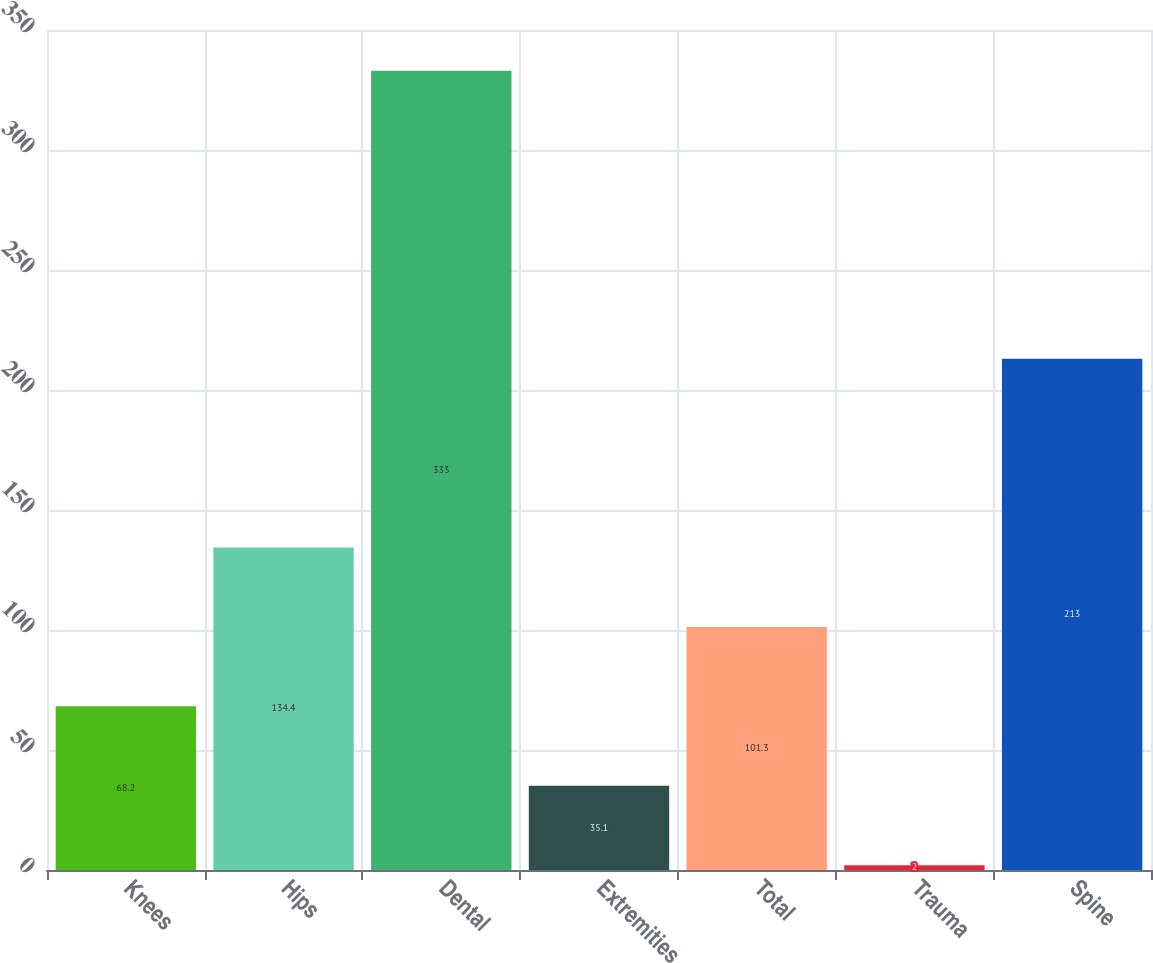Convert chart. <chart><loc_0><loc_0><loc_500><loc_500><bar_chart><fcel>Knees<fcel>Hips<fcel>Dental<fcel>Extremities<fcel>Total<fcel>Trauma<fcel>Spine<nl><fcel>68.2<fcel>134.4<fcel>333<fcel>35.1<fcel>101.3<fcel>2<fcel>213<nl></chart> 